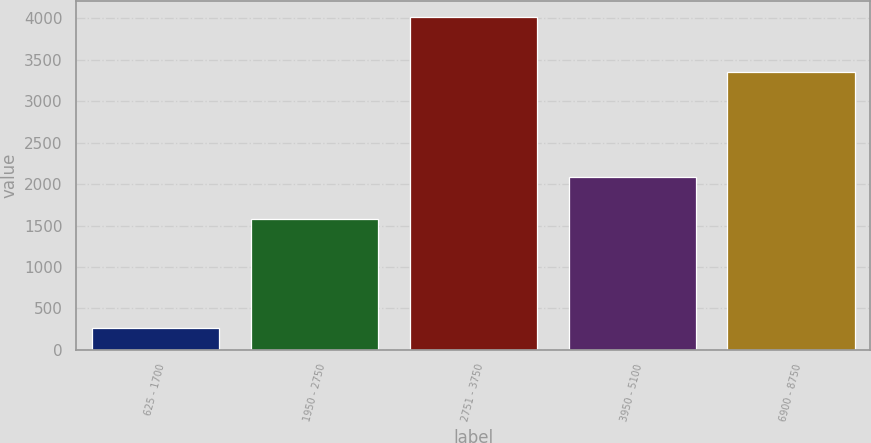Convert chart. <chart><loc_0><loc_0><loc_500><loc_500><bar_chart><fcel>625 - 1700<fcel>1950 - 2750<fcel>2751 - 3750<fcel>3950 - 5100<fcel>6900 - 8750<nl><fcel>259<fcel>1583<fcel>4012<fcel>2082<fcel>3355<nl></chart> 